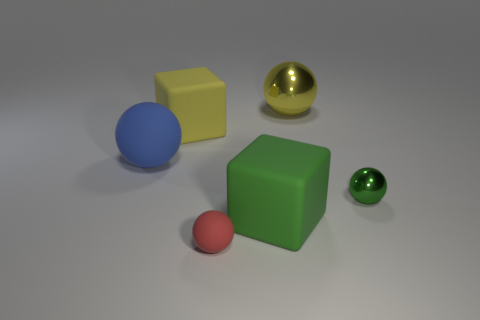Is the number of green objects that are in front of the red rubber thing less than the number of small yellow things? Actually, there is only one green object that appears to be in front of the red object, and there are no small yellow things in the image. Therefore, the number of green objects in front of the red object is not less than the number of small yellow things because there are no small yellow things to compare with. 